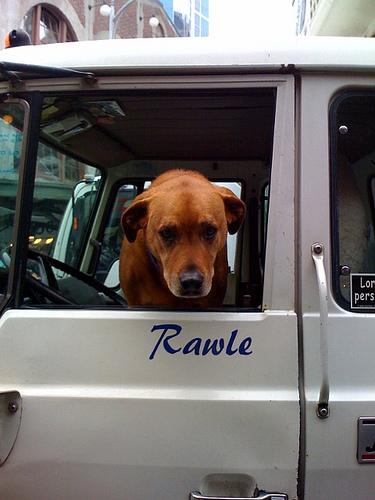What name is on the door?
Quick response, please. Rawle. Was this photo taken in the city?
Quick response, please. Yes. Where is the dog?
Quick response, please. In truck. 